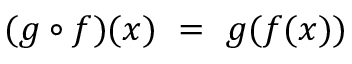<formula> <loc_0><loc_0><loc_500><loc_500>( g \circ f ) ( x ) \ = \ g ( f ( x ) )</formula> 